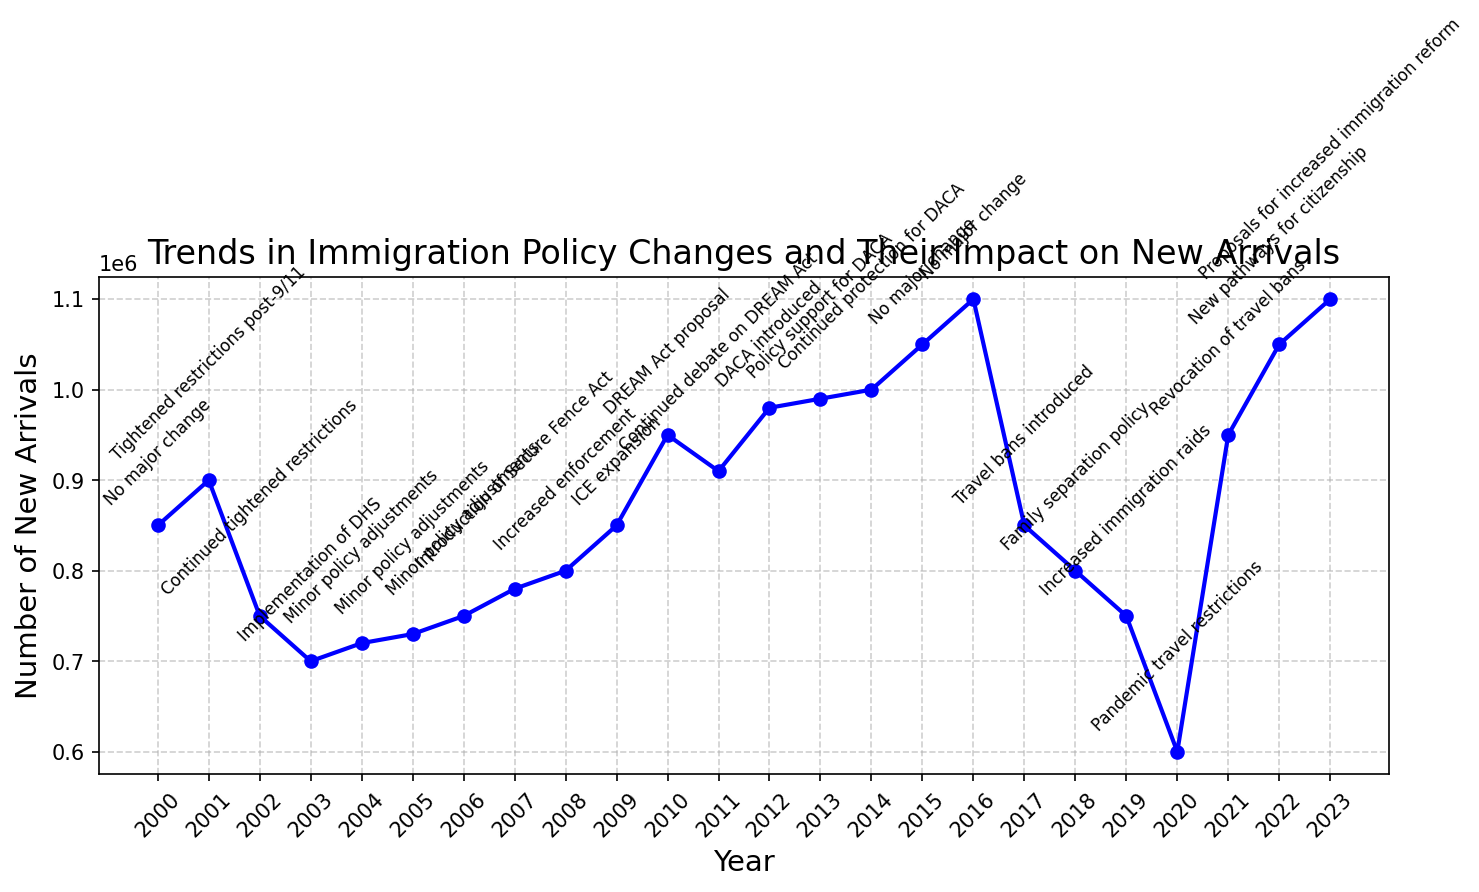What year had the lowest number of new arrivals? By observing the line chart, identify the lowest point on the graph (which represents the minimum number of new arrivals).
Answer: 2020 In which year did new arrivals first reach 1,000,000? Looking at the upward trend in the graph, find the first year after 2013 in which the line crosses the 1,000,000 new arrivals mark.
Answer: 2014 How did the introduction of the Secure Fence Act in 2007 affect new arrivals the following year? Observe the point marked as "Introduction of Secure Fence Act" in 2007 and compare it with the new arrivals in 2008. Notice if there's an increase or decrease.
Answer: Increased Which policy change coincided with a sharp increase in new arrivals after a significant drop in 2020? Locate the sharp drop to 600,000 in 2020 followed by a sharp increase in 2021, and note the policy change annotated for 2021.
Answer: Revocation of travel bans How many years did the tightened restrictions post-9/11 affect new arrivals? Identify the year the restrictions were introduced (2001) and observe the subsequent years with annotations showing continuous tightened restrictions ending with another major policy change.
Answer: 3 years What is the impact of the DREAM Act proposal on new arrivals in 2010 and the subsequent year? Check the new arrivals in the year when the DREAM Act was proposed (2010) and compare it with the subsequent year (2011). Notice any pattern (increase or decrease).
Answer: Increase How many years saw successive continuous growth in new arrivals before the drastic drop in 2017? Identify a consistent upward trend before the marked drop in 2017, noting the number of years the growth was uninterrupted.
Answer: 3 years Compare the number of new arrivals in the year with the Family separation policy to the number of new arrivals in the preceding and succeeding years. Locate the data points for 2018 (Family separation policy) and compare them with 2017 and 2019 to observe the relative differences.
Answer: Decreased in both preceding and succeeding years How did pandemic travel restrictions in 2020 alter the trend in new arrivals compared to the previous years? Identify the marked drop in 2020 and compare it with the trend in preceding years, noting any abrupt changes.
Answer: Sharp decline What was the pattern of new arrivals following the introduction of DACA in 2012 over the next three years? Check the plot starting from 2012 and observe the trend line for the subsequent three years to determine the movement.
Answer: Increasing 